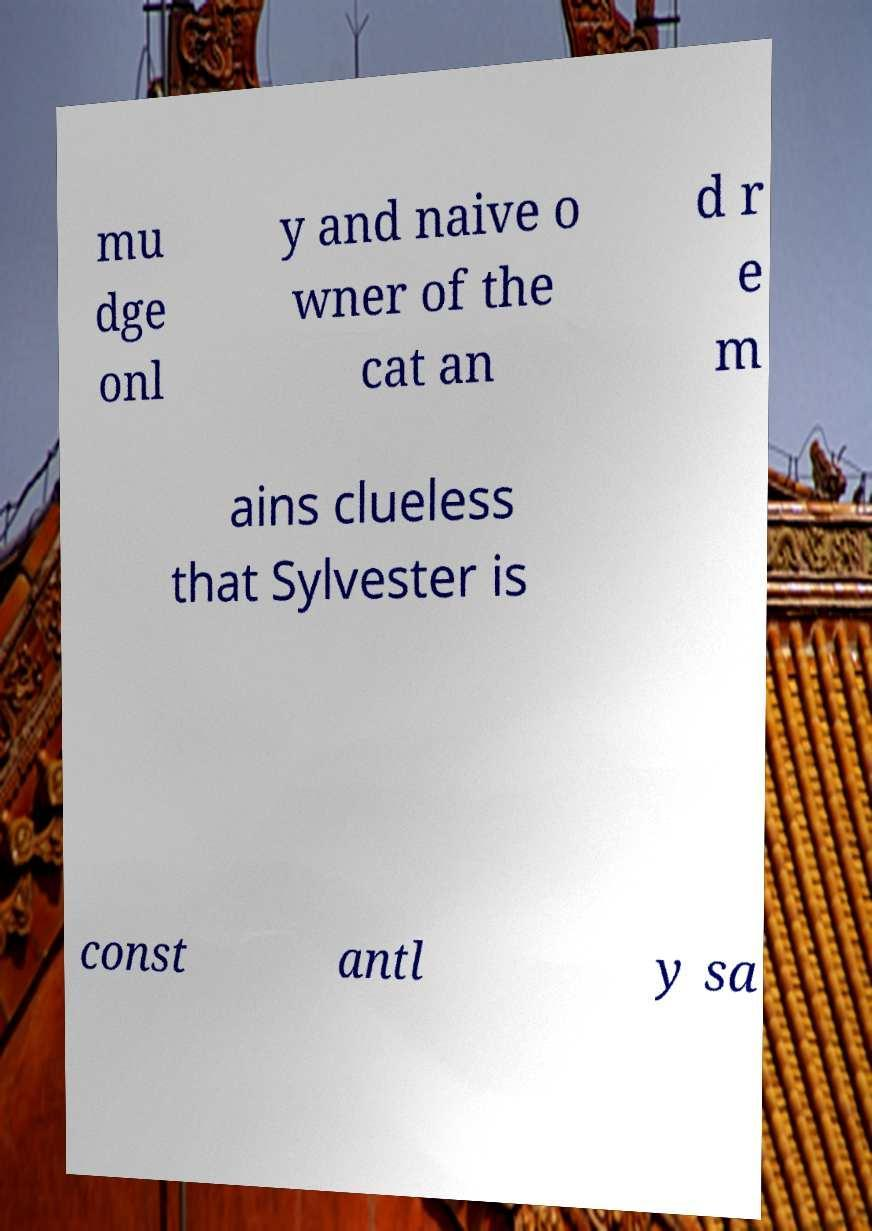There's text embedded in this image that I need extracted. Can you transcribe it verbatim? mu dge onl y and naive o wner of the cat an d r e m ains clueless that Sylvester is const antl y sa 